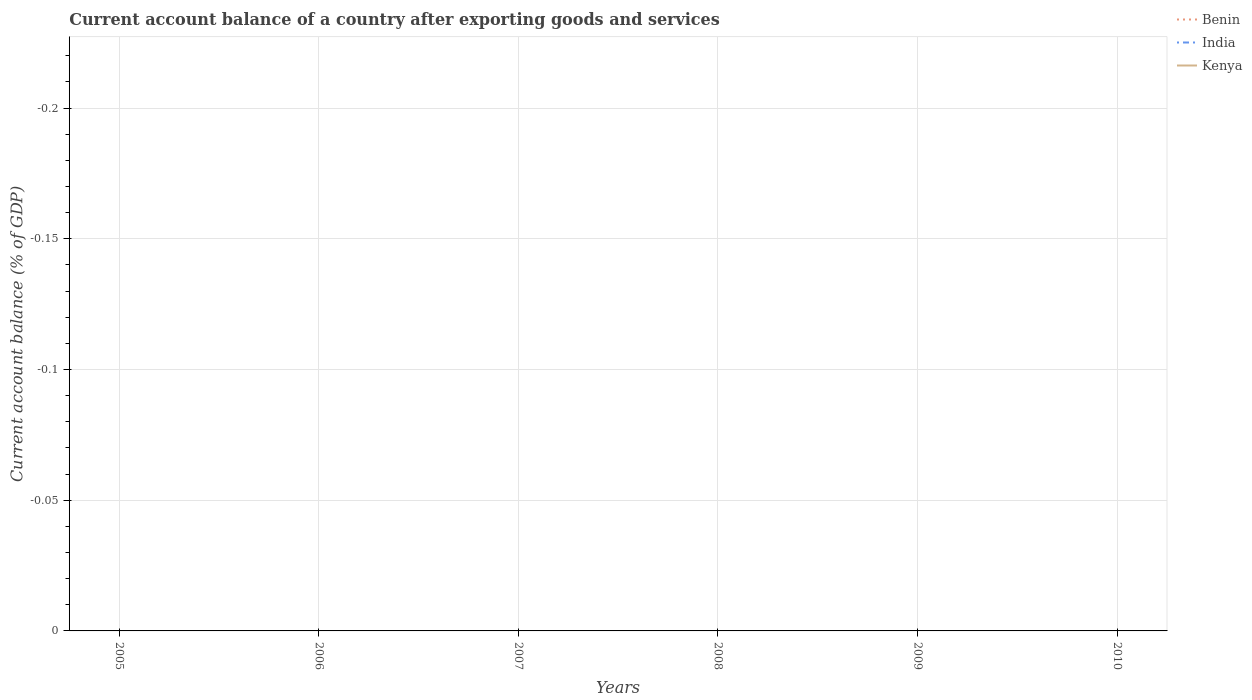How many different coloured lines are there?
Offer a terse response. 0. What is the difference between the highest and the lowest account balance in India?
Your response must be concise. 0. How many lines are there?
Offer a very short reply. 0. How many years are there in the graph?
Offer a terse response. 6. What is the difference between two consecutive major ticks on the Y-axis?
Your response must be concise. 0.05. Where does the legend appear in the graph?
Provide a succinct answer. Top right. What is the title of the graph?
Offer a very short reply. Current account balance of a country after exporting goods and services. Does "French Polynesia" appear as one of the legend labels in the graph?
Provide a succinct answer. No. What is the label or title of the Y-axis?
Your answer should be very brief. Current account balance (% of GDP). What is the Current account balance (% of GDP) of India in 2005?
Make the answer very short. 0. What is the Current account balance (% of GDP) in India in 2006?
Offer a terse response. 0. What is the Current account balance (% of GDP) of Kenya in 2007?
Make the answer very short. 0. What is the Current account balance (% of GDP) of Benin in 2008?
Offer a very short reply. 0. What is the Current account balance (% of GDP) of India in 2008?
Make the answer very short. 0. What is the Current account balance (% of GDP) in Benin in 2009?
Make the answer very short. 0. What is the Current account balance (% of GDP) in Kenya in 2009?
Your answer should be very brief. 0. What is the Current account balance (% of GDP) in India in 2010?
Keep it short and to the point. 0. What is the Current account balance (% of GDP) of Kenya in 2010?
Your answer should be very brief. 0. What is the average Current account balance (% of GDP) in Benin per year?
Make the answer very short. 0. What is the average Current account balance (% of GDP) in Kenya per year?
Your response must be concise. 0. 